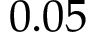Convert formula to latex. <formula><loc_0><loc_0><loc_500><loc_500>0 . 0 5</formula> 